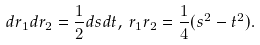Convert formula to latex. <formula><loc_0><loc_0><loc_500><loc_500>d r _ { 1 } d r _ { 2 } = \frac { 1 } { 2 } d s d t , \, r _ { 1 } r _ { 2 } = \frac { 1 } { 4 } ( s ^ { 2 } - t ^ { 2 } ) .</formula> 